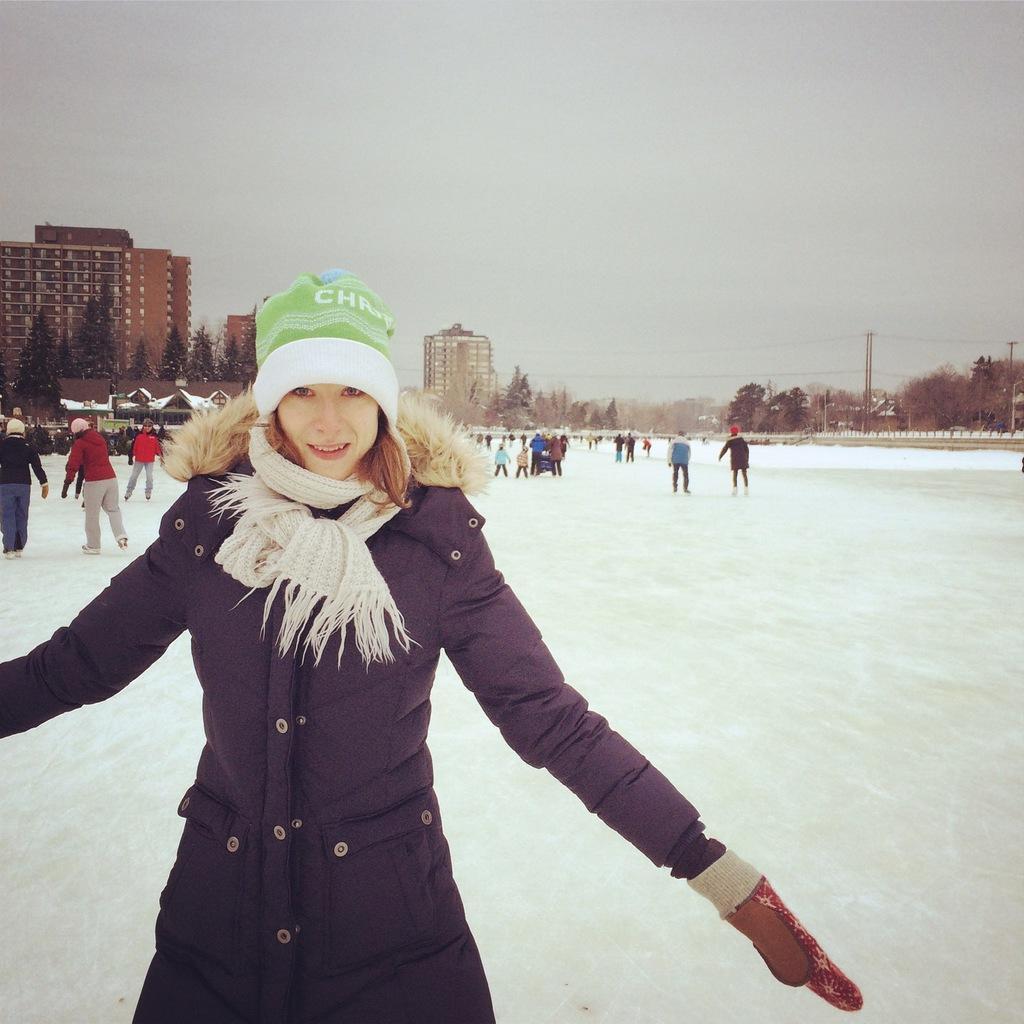How would you summarize this image in a sentence or two? In this picture there is a woman who is wearing cap, jacket, scarf, and gloves. He is standing on the snow. On the left there are two persons who are playing with the snow. In the background we can see many peoples were walking. On the left background we can see the buildings and trees. On the right background we can see an electric poles and wires. At the top we can see sky and clouds. 